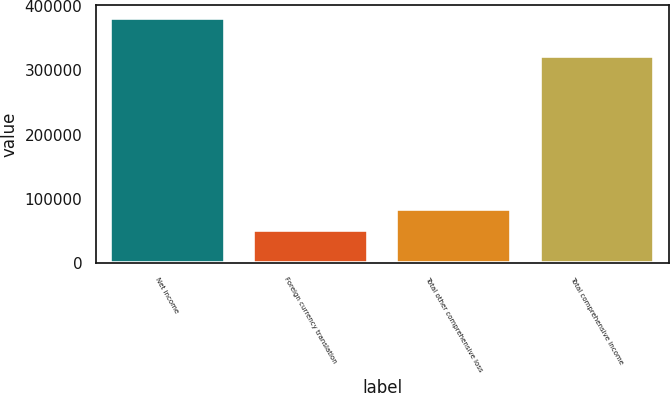Convert chart. <chart><loc_0><loc_0><loc_500><loc_500><bar_chart><fcel>Net income<fcel>Foreign currency translation<fcel>Total other comprehensive loss<fcel>Total comprehensive income<nl><fcel>381519<fcel>51979<fcel>84933<fcel>321283<nl></chart> 